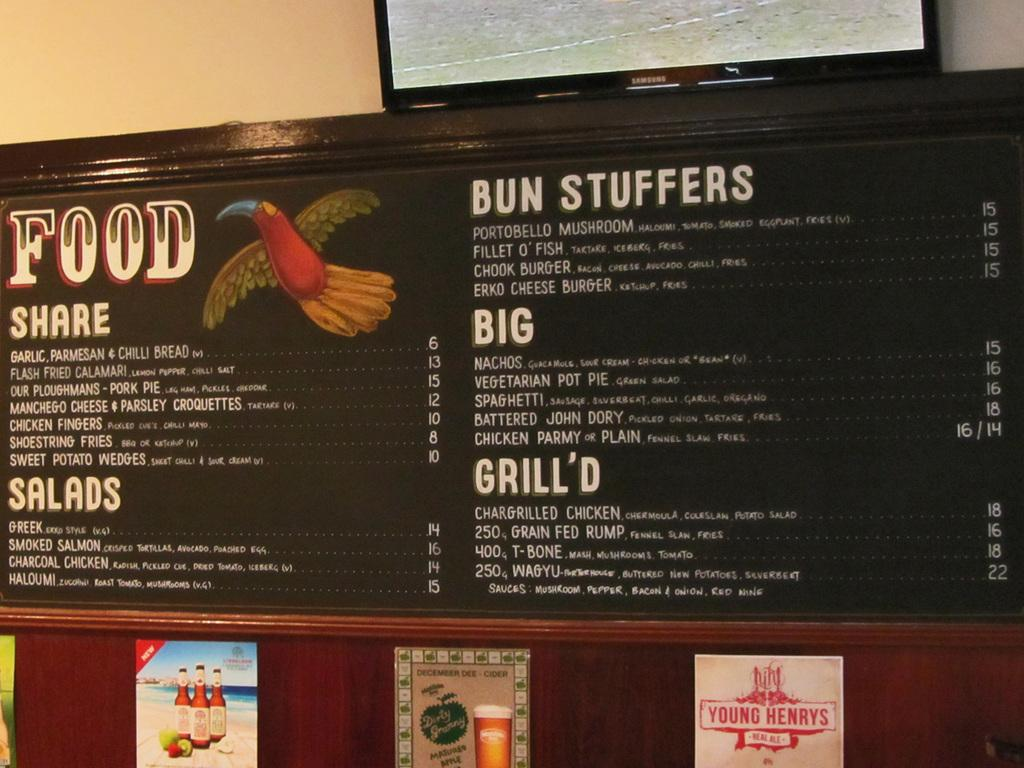<image>
Relay a brief, clear account of the picture shown. A menu shows options including salads, bun stuffers, big dishes, and grilled foods. 